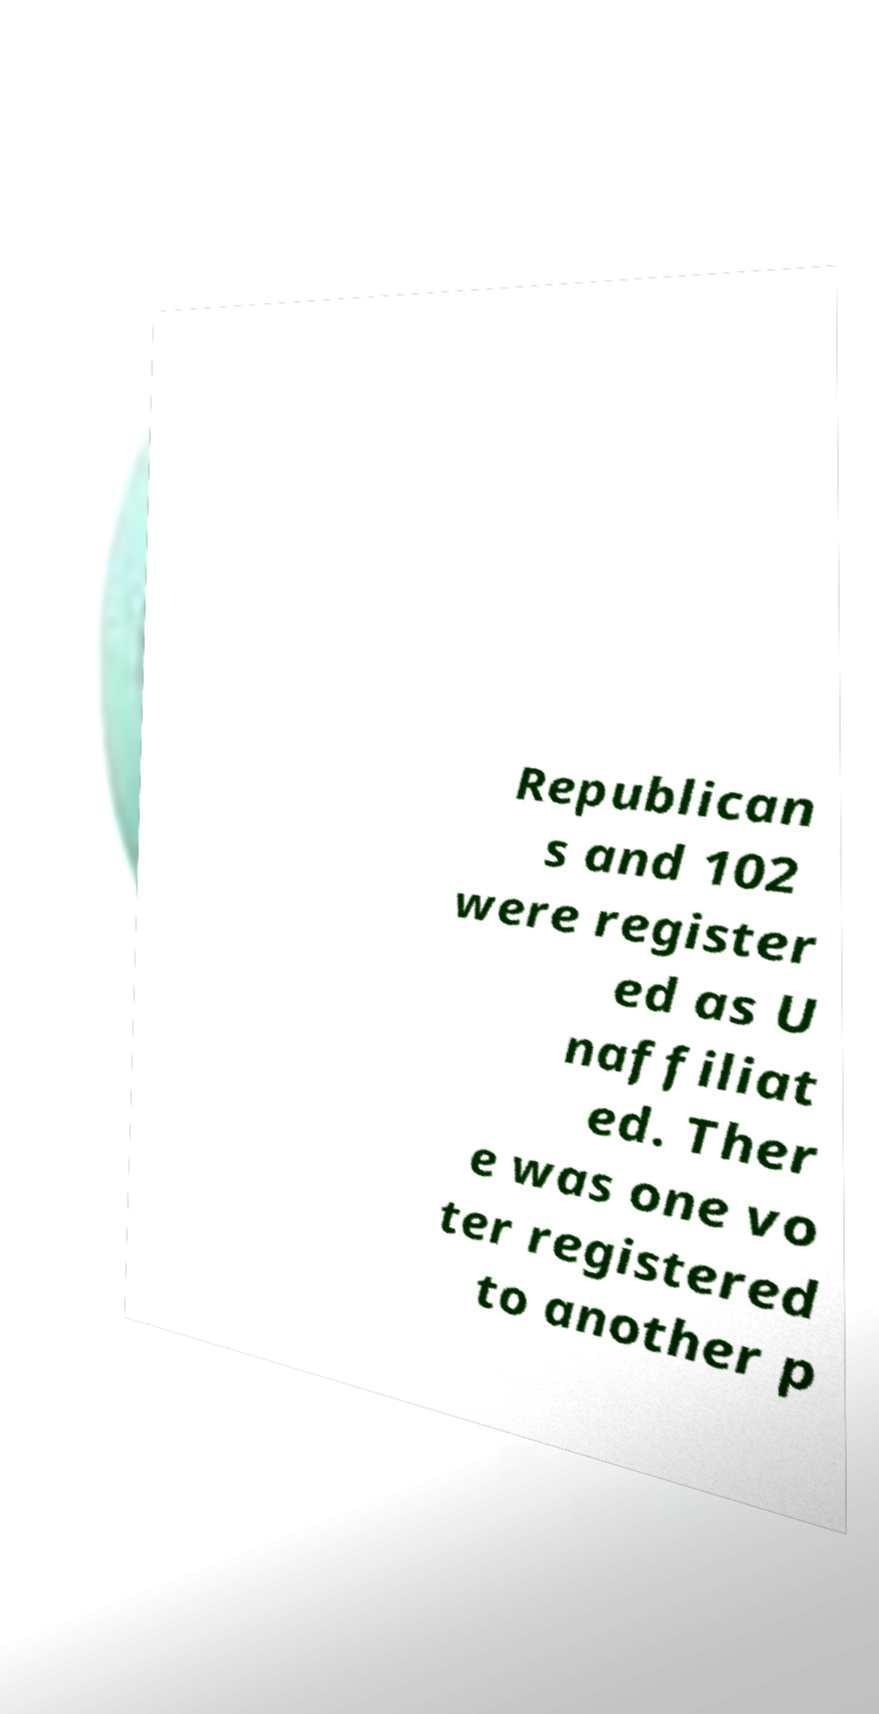What messages or text are displayed in this image? I need them in a readable, typed format. Republican s and 102 were register ed as U naffiliat ed. Ther e was one vo ter registered to another p 